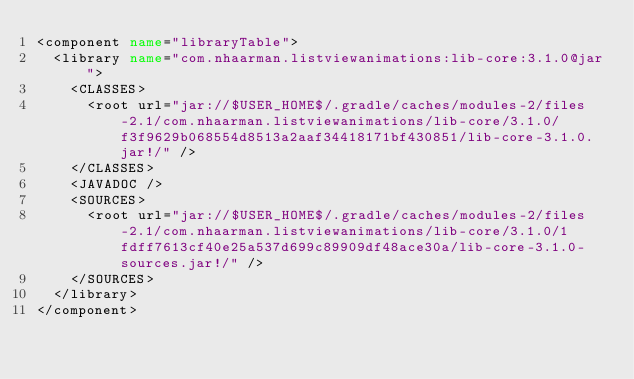<code> <loc_0><loc_0><loc_500><loc_500><_XML_><component name="libraryTable">
  <library name="com.nhaarman.listviewanimations:lib-core:3.1.0@jar">
    <CLASSES>
      <root url="jar://$USER_HOME$/.gradle/caches/modules-2/files-2.1/com.nhaarman.listviewanimations/lib-core/3.1.0/f3f9629b068554d8513a2aaf34418171bf430851/lib-core-3.1.0.jar!/" />
    </CLASSES>
    <JAVADOC />
    <SOURCES>
      <root url="jar://$USER_HOME$/.gradle/caches/modules-2/files-2.1/com.nhaarman.listviewanimations/lib-core/3.1.0/1fdff7613cf40e25a537d699c89909df48ace30a/lib-core-3.1.0-sources.jar!/" />
    </SOURCES>
  </library>
</component></code> 